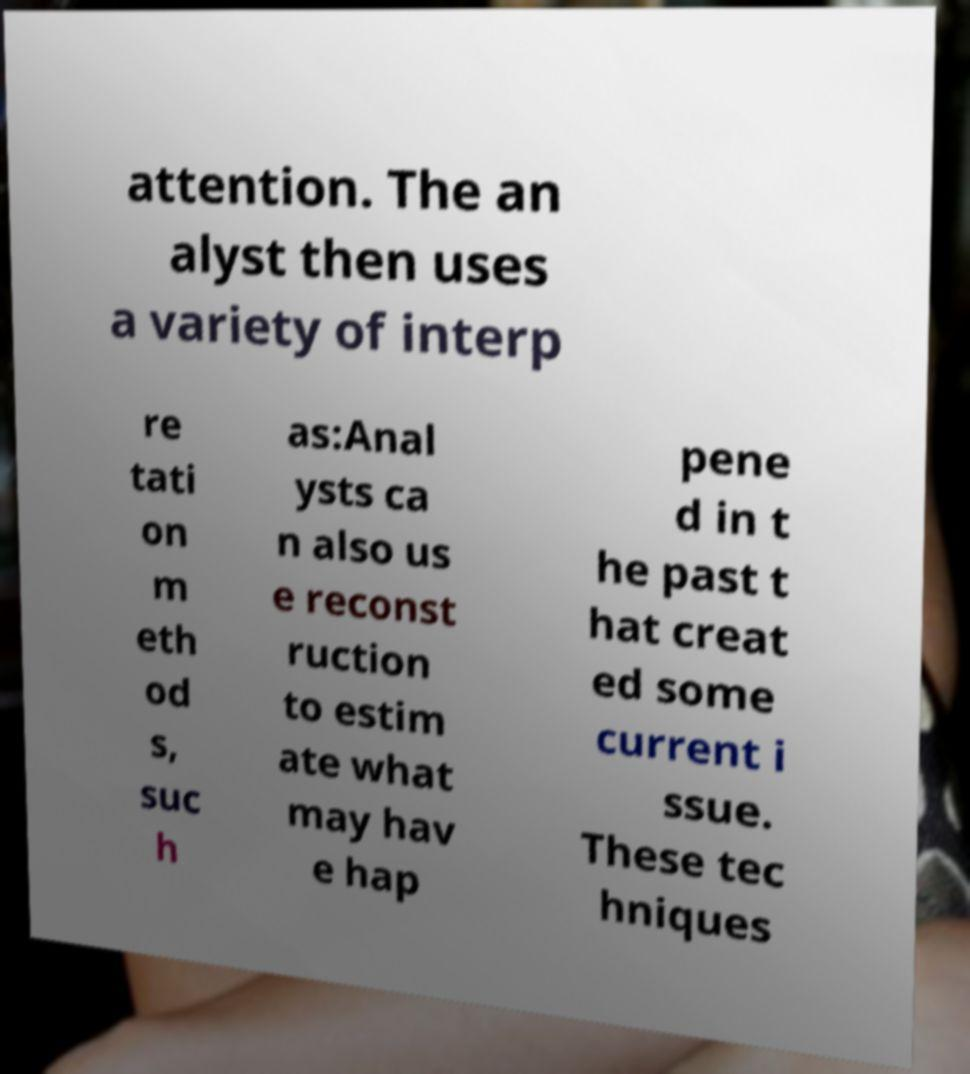For documentation purposes, I need the text within this image transcribed. Could you provide that? attention. The an alyst then uses a variety of interp re tati on m eth od s, suc h as:Anal ysts ca n also us e reconst ruction to estim ate what may hav e hap pene d in t he past t hat creat ed some current i ssue. These tec hniques 